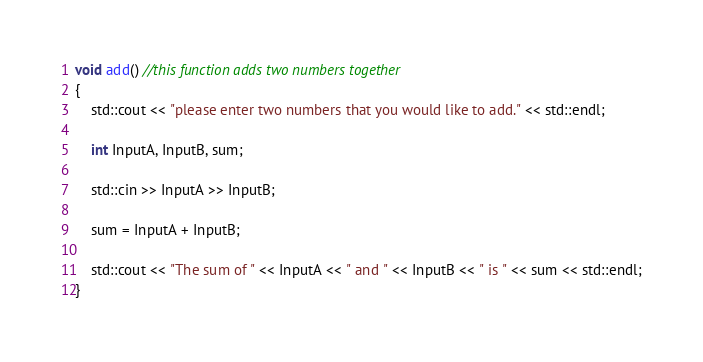<code> <loc_0><loc_0><loc_500><loc_500><_C_>void add() //this function adds two numbers together
{
	std::cout << "please enter two numbers that you would like to add." << std::endl;

	int InputA, InputB, sum;

	std::cin >> InputA >> InputB;

	sum = InputA + InputB;

	std::cout << "The sum of " << InputA << " and " << InputB << " is " << sum << std::endl;
}</code> 